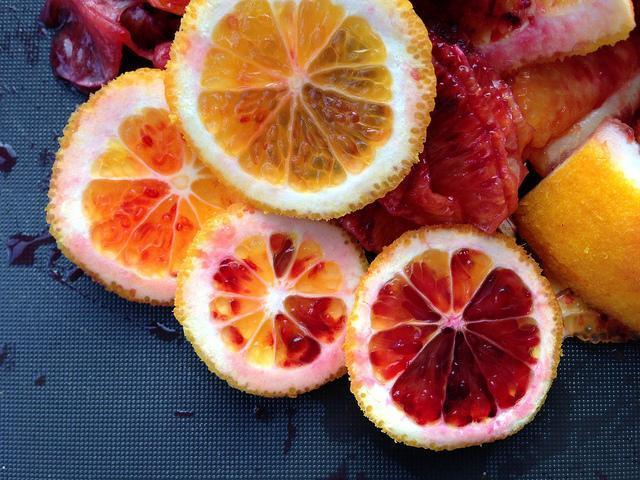How many women are in the picture?
Give a very brief answer. 0. 